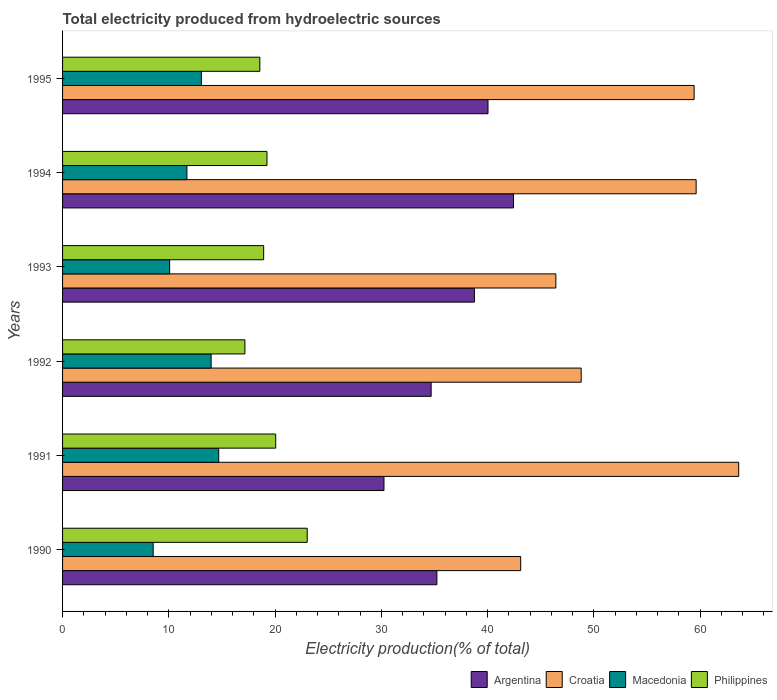How many different coloured bars are there?
Keep it short and to the point. 4. How many bars are there on the 1st tick from the top?
Your answer should be very brief. 4. What is the label of the 5th group of bars from the top?
Ensure brevity in your answer.  1991. In how many cases, is the number of bars for a given year not equal to the number of legend labels?
Ensure brevity in your answer.  0. What is the total electricity produced in Argentina in 1994?
Ensure brevity in your answer.  42.44. Across all years, what is the maximum total electricity produced in Philippines?
Provide a short and direct response. 23.03. Across all years, what is the minimum total electricity produced in Argentina?
Give a very brief answer. 30.25. In which year was the total electricity produced in Croatia maximum?
Keep it short and to the point. 1991. What is the total total electricity produced in Philippines in the graph?
Your answer should be compact. 116.98. What is the difference between the total electricity produced in Macedonia in 1993 and that in 1994?
Keep it short and to the point. -1.63. What is the difference between the total electricity produced in Argentina in 1990 and the total electricity produced in Croatia in 1992?
Your response must be concise. -13.58. What is the average total electricity produced in Argentina per year?
Your answer should be very brief. 36.9. In the year 1995, what is the difference between the total electricity produced in Argentina and total electricity produced in Philippines?
Offer a terse response. 21.47. What is the ratio of the total electricity produced in Macedonia in 1992 to that in 1995?
Your answer should be compact. 1.07. What is the difference between the highest and the second highest total electricity produced in Argentina?
Give a very brief answer. 2.4. What is the difference between the highest and the lowest total electricity produced in Croatia?
Your answer should be very brief. 20.52. In how many years, is the total electricity produced in Macedonia greater than the average total electricity produced in Macedonia taken over all years?
Give a very brief answer. 3. What does the 2nd bar from the top in 1991 represents?
Give a very brief answer. Macedonia. Is it the case that in every year, the sum of the total electricity produced in Macedonia and total electricity produced in Argentina is greater than the total electricity produced in Philippines?
Offer a terse response. Yes. How many bars are there?
Your response must be concise. 24. What is the difference between two consecutive major ticks on the X-axis?
Provide a succinct answer. 10. Does the graph contain any zero values?
Ensure brevity in your answer.  No. Does the graph contain grids?
Provide a short and direct response. No. Where does the legend appear in the graph?
Provide a succinct answer. Bottom right. How many legend labels are there?
Your response must be concise. 4. How are the legend labels stacked?
Give a very brief answer. Horizontal. What is the title of the graph?
Keep it short and to the point. Total electricity produced from hydroelectric sources. Does "Philippines" appear as one of the legend labels in the graph?
Your answer should be compact. Yes. What is the label or title of the X-axis?
Make the answer very short. Electricity production(% of total). What is the Electricity production(% of total) in Argentina in 1990?
Make the answer very short. 35.23. What is the Electricity production(% of total) in Croatia in 1990?
Ensure brevity in your answer.  43.12. What is the Electricity production(% of total) of Macedonia in 1990?
Your answer should be very brief. 8.53. What is the Electricity production(% of total) in Philippines in 1990?
Make the answer very short. 23.03. What is the Electricity production(% of total) of Argentina in 1991?
Provide a short and direct response. 30.25. What is the Electricity production(% of total) in Croatia in 1991?
Keep it short and to the point. 63.63. What is the Electricity production(% of total) in Macedonia in 1991?
Make the answer very short. 14.7. What is the Electricity production(% of total) in Philippines in 1991?
Your answer should be compact. 20.06. What is the Electricity production(% of total) of Argentina in 1992?
Provide a succinct answer. 34.69. What is the Electricity production(% of total) in Croatia in 1992?
Offer a terse response. 48.81. What is the Electricity production(% of total) in Macedonia in 1992?
Ensure brevity in your answer.  13.98. What is the Electricity production(% of total) of Philippines in 1992?
Your answer should be compact. 17.16. What is the Electricity production(% of total) in Argentina in 1993?
Offer a terse response. 38.76. What is the Electricity production(% of total) of Croatia in 1993?
Keep it short and to the point. 46.43. What is the Electricity production(% of total) of Macedonia in 1993?
Your response must be concise. 10.08. What is the Electricity production(% of total) in Philippines in 1993?
Your response must be concise. 18.92. What is the Electricity production(% of total) of Argentina in 1994?
Provide a succinct answer. 42.44. What is the Electricity production(% of total) of Croatia in 1994?
Offer a terse response. 59.63. What is the Electricity production(% of total) in Macedonia in 1994?
Offer a terse response. 11.7. What is the Electricity production(% of total) of Philippines in 1994?
Your response must be concise. 19.24. What is the Electricity production(% of total) in Argentina in 1995?
Keep it short and to the point. 40.04. What is the Electricity production(% of total) of Croatia in 1995?
Make the answer very short. 59.44. What is the Electricity production(% of total) of Macedonia in 1995?
Provide a succinct answer. 13.06. What is the Electricity production(% of total) of Philippines in 1995?
Give a very brief answer. 18.57. Across all years, what is the maximum Electricity production(% of total) in Argentina?
Your answer should be compact. 42.44. Across all years, what is the maximum Electricity production(% of total) of Croatia?
Offer a very short reply. 63.63. Across all years, what is the maximum Electricity production(% of total) of Macedonia?
Make the answer very short. 14.7. Across all years, what is the maximum Electricity production(% of total) in Philippines?
Make the answer very short. 23.03. Across all years, what is the minimum Electricity production(% of total) in Argentina?
Provide a succinct answer. 30.25. Across all years, what is the minimum Electricity production(% of total) in Croatia?
Offer a terse response. 43.12. Across all years, what is the minimum Electricity production(% of total) in Macedonia?
Give a very brief answer. 8.53. Across all years, what is the minimum Electricity production(% of total) of Philippines?
Your answer should be compact. 17.16. What is the total Electricity production(% of total) of Argentina in the graph?
Ensure brevity in your answer.  221.41. What is the total Electricity production(% of total) in Croatia in the graph?
Give a very brief answer. 321.05. What is the total Electricity production(% of total) in Macedonia in the graph?
Make the answer very short. 72.05. What is the total Electricity production(% of total) in Philippines in the graph?
Provide a short and direct response. 116.98. What is the difference between the Electricity production(% of total) in Argentina in 1990 and that in 1991?
Ensure brevity in your answer.  4.98. What is the difference between the Electricity production(% of total) in Croatia in 1990 and that in 1991?
Keep it short and to the point. -20.52. What is the difference between the Electricity production(% of total) of Macedonia in 1990 and that in 1991?
Make the answer very short. -6.17. What is the difference between the Electricity production(% of total) of Philippines in 1990 and that in 1991?
Offer a terse response. 2.97. What is the difference between the Electricity production(% of total) in Argentina in 1990 and that in 1992?
Your answer should be compact. 0.54. What is the difference between the Electricity production(% of total) in Croatia in 1990 and that in 1992?
Offer a terse response. -5.69. What is the difference between the Electricity production(% of total) in Macedonia in 1990 and that in 1992?
Offer a terse response. -5.45. What is the difference between the Electricity production(% of total) in Philippines in 1990 and that in 1992?
Offer a very short reply. 5.86. What is the difference between the Electricity production(% of total) of Argentina in 1990 and that in 1993?
Provide a succinct answer. -3.53. What is the difference between the Electricity production(% of total) of Croatia in 1990 and that in 1993?
Provide a succinct answer. -3.31. What is the difference between the Electricity production(% of total) in Macedonia in 1990 and that in 1993?
Ensure brevity in your answer.  -1.55. What is the difference between the Electricity production(% of total) in Philippines in 1990 and that in 1993?
Ensure brevity in your answer.  4.1. What is the difference between the Electricity production(% of total) in Argentina in 1990 and that in 1994?
Provide a succinct answer. -7.21. What is the difference between the Electricity production(% of total) in Croatia in 1990 and that in 1994?
Keep it short and to the point. -16.51. What is the difference between the Electricity production(% of total) of Macedonia in 1990 and that in 1994?
Make the answer very short. -3.17. What is the difference between the Electricity production(% of total) in Philippines in 1990 and that in 1994?
Ensure brevity in your answer.  3.79. What is the difference between the Electricity production(% of total) of Argentina in 1990 and that in 1995?
Your response must be concise. -4.81. What is the difference between the Electricity production(% of total) in Croatia in 1990 and that in 1995?
Offer a terse response. -16.32. What is the difference between the Electricity production(% of total) of Macedonia in 1990 and that in 1995?
Ensure brevity in your answer.  -4.54. What is the difference between the Electricity production(% of total) of Philippines in 1990 and that in 1995?
Offer a terse response. 4.46. What is the difference between the Electricity production(% of total) of Argentina in 1991 and that in 1992?
Give a very brief answer. -4.44. What is the difference between the Electricity production(% of total) in Croatia in 1991 and that in 1992?
Keep it short and to the point. 14.82. What is the difference between the Electricity production(% of total) in Macedonia in 1991 and that in 1992?
Your answer should be very brief. 0.71. What is the difference between the Electricity production(% of total) of Philippines in 1991 and that in 1992?
Your answer should be compact. 2.9. What is the difference between the Electricity production(% of total) of Argentina in 1991 and that in 1993?
Make the answer very short. -8.51. What is the difference between the Electricity production(% of total) of Croatia in 1991 and that in 1993?
Your answer should be compact. 17.21. What is the difference between the Electricity production(% of total) of Macedonia in 1991 and that in 1993?
Your response must be concise. 4.62. What is the difference between the Electricity production(% of total) of Philippines in 1991 and that in 1993?
Your answer should be very brief. 1.13. What is the difference between the Electricity production(% of total) in Argentina in 1991 and that in 1994?
Your answer should be very brief. -12.19. What is the difference between the Electricity production(% of total) in Croatia in 1991 and that in 1994?
Offer a terse response. 4. What is the difference between the Electricity production(% of total) in Macedonia in 1991 and that in 1994?
Offer a terse response. 2.99. What is the difference between the Electricity production(% of total) in Philippines in 1991 and that in 1994?
Give a very brief answer. 0.82. What is the difference between the Electricity production(% of total) in Argentina in 1991 and that in 1995?
Offer a terse response. -9.79. What is the difference between the Electricity production(% of total) in Croatia in 1991 and that in 1995?
Your answer should be compact. 4.19. What is the difference between the Electricity production(% of total) in Macedonia in 1991 and that in 1995?
Provide a short and direct response. 1.63. What is the difference between the Electricity production(% of total) in Philippines in 1991 and that in 1995?
Ensure brevity in your answer.  1.49. What is the difference between the Electricity production(% of total) of Argentina in 1992 and that in 1993?
Give a very brief answer. -4.07. What is the difference between the Electricity production(% of total) in Croatia in 1992 and that in 1993?
Make the answer very short. 2.38. What is the difference between the Electricity production(% of total) of Macedonia in 1992 and that in 1993?
Give a very brief answer. 3.9. What is the difference between the Electricity production(% of total) of Philippines in 1992 and that in 1993?
Keep it short and to the point. -1.76. What is the difference between the Electricity production(% of total) of Argentina in 1992 and that in 1994?
Offer a very short reply. -7.75. What is the difference between the Electricity production(% of total) in Croatia in 1992 and that in 1994?
Keep it short and to the point. -10.82. What is the difference between the Electricity production(% of total) of Macedonia in 1992 and that in 1994?
Offer a terse response. 2.28. What is the difference between the Electricity production(% of total) of Philippines in 1992 and that in 1994?
Offer a very short reply. -2.08. What is the difference between the Electricity production(% of total) in Argentina in 1992 and that in 1995?
Keep it short and to the point. -5.35. What is the difference between the Electricity production(% of total) of Croatia in 1992 and that in 1995?
Give a very brief answer. -10.63. What is the difference between the Electricity production(% of total) of Macedonia in 1992 and that in 1995?
Provide a short and direct response. 0.92. What is the difference between the Electricity production(% of total) of Philippines in 1992 and that in 1995?
Give a very brief answer. -1.4. What is the difference between the Electricity production(% of total) of Argentina in 1993 and that in 1994?
Your answer should be compact. -3.68. What is the difference between the Electricity production(% of total) in Croatia in 1993 and that in 1994?
Your response must be concise. -13.2. What is the difference between the Electricity production(% of total) in Macedonia in 1993 and that in 1994?
Ensure brevity in your answer.  -1.63. What is the difference between the Electricity production(% of total) of Philippines in 1993 and that in 1994?
Offer a terse response. -0.31. What is the difference between the Electricity production(% of total) in Argentina in 1993 and that in 1995?
Give a very brief answer. -1.28. What is the difference between the Electricity production(% of total) in Croatia in 1993 and that in 1995?
Provide a short and direct response. -13.01. What is the difference between the Electricity production(% of total) in Macedonia in 1993 and that in 1995?
Give a very brief answer. -2.99. What is the difference between the Electricity production(% of total) of Philippines in 1993 and that in 1995?
Your answer should be very brief. 0.36. What is the difference between the Electricity production(% of total) in Argentina in 1994 and that in 1995?
Offer a terse response. 2.4. What is the difference between the Electricity production(% of total) in Croatia in 1994 and that in 1995?
Keep it short and to the point. 0.19. What is the difference between the Electricity production(% of total) in Macedonia in 1994 and that in 1995?
Provide a succinct answer. -1.36. What is the difference between the Electricity production(% of total) in Philippines in 1994 and that in 1995?
Give a very brief answer. 0.67. What is the difference between the Electricity production(% of total) of Argentina in 1990 and the Electricity production(% of total) of Croatia in 1991?
Keep it short and to the point. -28.4. What is the difference between the Electricity production(% of total) of Argentina in 1990 and the Electricity production(% of total) of Macedonia in 1991?
Ensure brevity in your answer.  20.53. What is the difference between the Electricity production(% of total) in Argentina in 1990 and the Electricity production(% of total) in Philippines in 1991?
Ensure brevity in your answer.  15.17. What is the difference between the Electricity production(% of total) in Croatia in 1990 and the Electricity production(% of total) in Macedonia in 1991?
Provide a succinct answer. 28.42. What is the difference between the Electricity production(% of total) of Croatia in 1990 and the Electricity production(% of total) of Philippines in 1991?
Your response must be concise. 23.06. What is the difference between the Electricity production(% of total) in Macedonia in 1990 and the Electricity production(% of total) in Philippines in 1991?
Ensure brevity in your answer.  -11.53. What is the difference between the Electricity production(% of total) of Argentina in 1990 and the Electricity production(% of total) of Croatia in 1992?
Provide a short and direct response. -13.58. What is the difference between the Electricity production(% of total) of Argentina in 1990 and the Electricity production(% of total) of Macedonia in 1992?
Provide a short and direct response. 21.25. What is the difference between the Electricity production(% of total) in Argentina in 1990 and the Electricity production(% of total) in Philippines in 1992?
Provide a short and direct response. 18.07. What is the difference between the Electricity production(% of total) in Croatia in 1990 and the Electricity production(% of total) in Macedonia in 1992?
Keep it short and to the point. 29.13. What is the difference between the Electricity production(% of total) in Croatia in 1990 and the Electricity production(% of total) in Philippines in 1992?
Provide a succinct answer. 25.95. What is the difference between the Electricity production(% of total) of Macedonia in 1990 and the Electricity production(% of total) of Philippines in 1992?
Provide a short and direct response. -8.64. What is the difference between the Electricity production(% of total) in Argentina in 1990 and the Electricity production(% of total) in Croatia in 1993?
Give a very brief answer. -11.2. What is the difference between the Electricity production(% of total) of Argentina in 1990 and the Electricity production(% of total) of Macedonia in 1993?
Provide a succinct answer. 25.15. What is the difference between the Electricity production(% of total) of Argentina in 1990 and the Electricity production(% of total) of Philippines in 1993?
Ensure brevity in your answer.  16.31. What is the difference between the Electricity production(% of total) in Croatia in 1990 and the Electricity production(% of total) in Macedonia in 1993?
Ensure brevity in your answer.  33.04. What is the difference between the Electricity production(% of total) in Croatia in 1990 and the Electricity production(% of total) in Philippines in 1993?
Provide a succinct answer. 24.19. What is the difference between the Electricity production(% of total) of Macedonia in 1990 and the Electricity production(% of total) of Philippines in 1993?
Keep it short and to the point. -10.4. What is the difference between the Electricity production(% of total) of Argentina in 1990 and the Electricity production(% of total) of Croatia in 1994?
Your response must be concise. -24.4. What is the difference between the Electricity production(% of total) of Argentina in 1990 and the Electricity production(% of total) of Macedonia in 1994?
Offer a very short reply. 23.53. What is the difference between the Electricity production(% of total) in Argentina in 1990 and the Electricity production(% of total) in Philippines in 1994?
Your answer should be compact. 15.99. What is the difference between the Electricity production(% of total) of Croatia in 1990 and the Electricity production(% of total) of Macedonia in 1994?
Offer a very short reply. 31.41. What is the difference between the Electricity production(% of total) in Croatia in 1990 and the Electricity production(% of total) in Philippines in 1994?
Ensure brevity in your answer.  23.88. What is the difference between the Electricity production(% of total) in Macedonia in 1990 and the Electricity production(% of total) in Philippines in 1994?
Your response must be concise. -10.71. What is the difference between the Electricity production(% of total) of Argentina in 1990 and the Electricity production(% of total) of Croatia in 1995?
Offer a terse response. -24.21. What is the difference between the Electricity production(% of total) of Argentina in 1990 and the Electricity production(% of total) of Macedonia in 1995?
Offer a terse response. 22.17. What is the difference between the Electricity production(% of total) in Argentina in 1990 and the Electricity production(% of total) in Philippines in 1995?
Your response must be concise. 16.66. What is the difference between the Electricity production(% of total) of Croatia in 1990 and the Electricity production(% of total) of Macedonia in 1995?
Keep it short and to the point. 30.05. What is the difference between the Electricity production(% of total) of Croatia in 1990 and the Electricity production(% of total) of Philippines in 1995?
Give a very brief answer. 24.55. What is the difference between the Electricity production(% of total) of Macedonia in 1990 and the Electricity production(% of total) of Philippines in 1995?
Your response must be concise. -10.04. What is the difference between the Electricity production(% of total) of Argentina in 1991 and the Electricity production(% of total) of Croatia in 1992?
Give a very brief answer. -18.56. What is the difference between the Electricity production(% of total) of Argentina in 1991 and the Electricity production(% of total) of Macedonia in 1992?
Give a very brief answer. 16.27. What is the difference between the Electricity production(% of total) of Argentina in 1991 and the Electricity production(% of total) of Philippines in 1992?
Ensure brevity in your answer.  13.09. What is the difference between the Electricity production(% of total) in Croatia in 1991 and the Electricity production(% of total) in Macedonia in 1992?
Provide a succinct answer. 49.65. What is the difference between the Electricity production(% of total) in Croatia in 1991 and the Electricity production(% of total) in Philippines in 1992?
Ensure brevity in your answer.  46.47. What is the difference between the Electricity production(% of total) of Macedonia in 1991 and the Electricity production(% of total) of Philippines in 1992?
Offer a very short reply. -2.47. What is the difference between the Electricity production(% of total) in Argentina in 1991 and the Electricity production(% of total) in Croatia in 1993?
Your answer should be very brief. -16.18. What is the difference between the Electricity production(% of total) of Argentina in 1991 and the Electricity production(% of total) of Macedonia in 1993?
Provide a short and direct response. 20.17. What is the difference between the Electricity production(% of total) of Argentina in 1991 and the Electricity production(% of total) of Philippines in 1993?
Your response must be concise. 11.33. What is the difference between the Electricity production(% of total) of Croatia in 1991 and the Electricity production(% of total) of Macedonia in 1993?
Give a very brief answer. 53.55. What is the difference between the Electricity production(% of total) in Croatia in 1991 and the Electricity production(% of total) in Philippines in 1993?
Keep it short and to the point. 44.71. What is the difference between the Electricity production(% of total) in Macedonia in 1991 and the Electricity production(% of total) in Philippines in 1993?
Your answer should be compact. -4.23. What is the difference between the Electricity production(% of total) of Argentina in 1991 and the Electricity production(% of total) of Croatia in 1994?
Offer a very short reply. -29.38. What is the difference between the Electricity production(% of total) in Argentina in 1991 and the Electricity production(% of total) in Macedonia in 1994?
Provide a succinct answer. 18.55. What is the difference between the Electricity production(% of total) of Argentina in 1991 and the Electricity production(% of total) of Philippines in 1994?
Provide a short and direct response. 11.01. What is the difference between the Electricity production(% of total) in Croatia in 1991 and the Electricity production(% of total) in Macedonia in 1994?
Your answer should be very brief. 51.93. What is the difference between the Electricity production(% of total) in Croatia in 1991 and the Electricity production(% of total) in Philippines in 1994?
Provide a succinct answer. 44.39. What is the difference between the Electricity production(% of total) in Macedonia in 1991 and the Electricity production(% of total) in Philippines in 1994?
Keep it short and to the point. -4.54. What is the difference between the Electricity production(% of total) in Argentina in 1991 and the Electricity production(% of total) in Croatia in 1995?
Ensure brevity in your answer.  -29.19. What is the difference between the Electricity production(% of total) in Argentina in 1991 and the Electricity production(% of total) in Macedonia in 1995?
Your answer should be very brief. 17.19. What is the difference between the Electricity production(% of total) of Argentina in 1991 and the Electricity production(% of total) of Philippines in 1995?
Offer a very short reply. 11.68. What is the difference between the Electricity production(% of total) of Croatia in 1991 and the Electricity production(% of total) of Macedonia in 1995?
Provide a succinct answer. 50.57. What is the difference between the Electricity production(% of total) of Croatia in 1991 and the Electricity production(% of total) of Philippines in 1995?
Keep it short and to the point. 45.07. What is the difference between the Electricity production(% of total) of Macedonia in 1991 and the Electricity production(% of total) of Philippines in 1995?
Ensure brevity in your answer.  -3.87. What is the difference between the Electricity production(% of total) in Argentina in 1992 and the Electricity production(% of total) in Croatia in 1993?
Make the answer very short. -11.74. What is the difference between the Electricity production(% of total) in Argentina in 1992 and the Electricity production(% of total) in Macedonia in 1993?
Your answer should be very brief. 24.61. What is the difference between the Electricity production(% of total) in Argentina in 1992 and the Electricity production(% of total) in Philippines in 1993?
Ensure brevity in your answer.  15.76. What is the difference between the Electricity production(% of total) in Croatia in 1992 and the Electricity production(% of total) in Macedonia in 1993?
Your answer should be compact. 38.73. What is the difference between the Electricity production(% of total) in Croatia in 1992 and the Electricity production(% of total) in Philippines in 1993?
Ensure brevity in your answer.  29.88. What is the difference between the Electricity production(% of total) in Macedonia in 1992 and the Electricity production(% of total) in Philippines in 1993?
Provide a short and direct response. -4.94. What is the difference between the Electricity production(% of total) of Argentina in 1992 and the Electricity production(% of total) of Croatia in 1994?
Keep it short and to the point. -24.94. What is the difference between the Electricity production(% of total) of Argentina in 1992 and the Electricity production(% of total) of Macedonia in 1994?
Keep it short and to the point. 22.99. What is the difference between the Electricity production(% of total) in Argentina in 1992 and the Electricity production(% of total) in Philippines in 1994?
Give a very brief answer. 15.45. What is the difference between the Electricity production(% of total) in Croatia in 1992 and the Electricity production(% of total) in Macedonia in 1994?
Ensure brevity in your answer.  37.11. What is the difference between the Electricity production(% of total) of Croatia in 1992 and the Electricity production(% of total) of Philippines in 1994?
Offer a very short reply. 29.57. What is the difference between the Electricity production(% of total) in Macedonia in 1992 and the Electricity production(% of total) in Philippines in 1994?
Provide a succinct answer. -5.26. What is the difference between the Electricity production(% of total) in Argentina in 1992 and the Electricity production(% of total) in Croatia in 1995?
Ensure brevity in your answer.  -24.75. What is the difference between the Electricity production(% of total) of Argentina in 1992 and the Electricity production(% of total) of Macedonia in 1995?
Your answer should be compact. 21.63. What is the difference between the Electricity production(% of total) in Argentina in 1992 and the Electricity production(% of total) in Philippines in 1995?
Ensure brevity in your answer.  16.12. What is the difference between the Electricity production(% of total) in Croatia in 1992 and the Electricity production(% of total) in Macedonia in 1995?
Your answer should be compact. 35.75. What is the difference between the Electricity production(% of total) in Croatia in 1992 and the Electricity production(% of total) in Philippines in 1995?
Ensure brevity in your answer.  30.24. What is the difference between the Electricity production(% of total) of Macedonia in 1992 and the Electricity production(% of total) of Philippines in 1995?
Make the answer very short. -4.58. What is the difference between the Electricity production(% of total) in Argentina in 1993 and the Electricity production(% of total) in Croatia in 1994?
Make the answer very short. -20.87. What is the difference between the Electricity production(% of total) of Argentina in 1993 and the Electricity production(% of total) of Macedonia in 1994?
Provide a short and direct response. 27.06. What is the difference between the Electricity production(% of total) of Argentina in 1993 and the Electricity production(% of total) of Philippines in 1994?
Offer a very short reply. 19.52. What is the difference between the Electricity production(% of total) of Croatia in 1993 and the Electricity production(% of total) of Macedonia in 1994?
Make the answer very short. 34.72. What is the difference between the Electricity production(% of total) in Croatia in 1993 and the Electricity production(% of total) in Philippines in 1994?
Your answer should be compact. 27.19. What is the difference between the Electricity production(% of total) in Macedonia in 1993 and the Electricity production(% of total) in Philippines in 1994?
Ensure brevity in your answer.  -9.16. What is the difference between the Electricity production(% of total) in Argentina in 1993 and the Electricity production(% of total) in Croatia in 1995?
Your answer should be compact. -20.68. What is the difference between the Electricity production(% of total) in Argentina in 1993 and the Electricity production(% of total) in Macedonia in 1995?
Your response must be concise. 25.7. What is the difference between the Electricity production(% of total) of Argentina in 1993 and the Electricity production(% of total) of Philippines in 1995?
Give a very brief answer. 20.19. What is the difference between the Electricity production(% of total) in Croatia in 1993 and the Electricity production(% of total) in Macedonia in 1995?
Your response must be concise. 33.36. What is the difference between the Electricity production(% of total) of Croatia in 1993 and the Electricity production(% of total) of Philippines in 1995?
Offer a terse response. 27.86. What is the difference between the Electricity production(% of total) in Macedonia in 1993 and the Electricity production(% of total) in Philippines in 1995?
Your response must be concise. -8.49. What is the difference between the Electricity production(% of total) of Argentina in 1994 and the Electricity production(% of total) of Croatia in 1995?
Give a very brief answer. -17. What is the difference between the Electricity production(% of total) in Argentina in 1994 and the Electricity production(% of total) in Macedonia in 1995?
Ensure brevity in your answer.  29.38. What is the difference between the Electricity production(% of total) of Argentina in 1994 and the Electricity production(% of total) of Philippines in 1995?
Give a very brief answer. 23.87. What is the difference between the Electricity production(% of total) of Croatia in 1994 and the Electricity production(% of total) of Macedonia in 1995?
Your answer should be compact. 46.56. What is the difference between the Electricity production(% of total) of Croatia in 1994 and the Electricity production(% of total) of Philippines in 1995?
Provide a succinct answer. 41.06. What is the difference between the Electricity production(% of total) in Macedonia in 1994 and the Electricity production(% of total) in Philippines in 1995?
Your response must be concise. -6.86. What is the average Electricity production(% of total) of Argentina per year?
Offer a very short reply. 36.9. What is the average Electricity production(% of total) in Croatia per year?
Provide a short and direct response. 53.51. What is the average Electricity production(% of total) of Macedonia per year?
Provide a short and direct response. 12.01. What is the average Electricity production(% of total) in Philippines per year?
Offer a terse response. 19.5. In the year 1990, what is the difference between the Electricity production(% of total) of Argentina and Electricity production(% of total) of Croatia?
Provide a succinct answer. -7.88. In the year 1990, what is the difference between the Electricity production(% of total) in Argentina and Electricity production(% of total) in Macedonia?
Offer a very short reply. 26.7. In the year 1990, what is the difference between the Electricity production(% of total) in Argentina and Electricity production(% of total) in Philippines?
Your answer should be compact. 12.2. In the year 1990, what is the difference between the Electricity production(% of total) of Croatia and Electricity production(% of total) of Macedonia?
Offer a terse response. 34.59. In the year 1990, what is the difference between the Electricity production(% of total) of Croatia and Electricity production(% of total) of Philippines?
Your answer should be compact. 20.09. In the year 1990, what is the difference between the Electricity production(% of total) in Macedonia and Electricity production(% of total) in Philippines?
Offer a terse response. -14.5. In the year 1991, what is the difference between the Electricity production(% of total) of Argentina and Electricity production(% of total) of Croatia?
Provide a short and direct response. -33.38. In the year 1991, what is the difference between the Electricity production(% of total) of Argentina and Electricity production(% of total) of Macedonia?
Offer a terse response. 15.55. In the year 1991, what is the difference between the Electricity production(% of total) of Argentina and Electricity production(% of total) of Philippines?
Keep it short and to the point. 10.19. In the year 1991, what is the difference between the Electricity production(% of total) in Croatia and Electricity production(% of total) in Macedonia?
Make the answer very short. 48.94. In the year 1991, what is the difference between the Electricity production(% of total) in Croatia and Electricity production(% of total) in Philippines?
Provide a short and direct response. 43.57. In the year 1991, what is the difference between the Electricity production(% of total) of Macedonia and Electricity production(% of total) of Philippines?
Provide a succinct answer. -5.36. In the year 1992, what is the difference between the Electricity production(% of total) in Argentina and Electricity production(% of total) in Croatia?
Make the answer very short. -14.12. In the year 1992, what is the difference between the Electricity production(% of total) in Argentina and Electricity production(% of total) in Macedonia?
Offer a very short reply. 20.71. In the year 1992, what is the difference between the Electricity production(% of total) of Argentina and Electricity production(% of total) of Philippines?
Provide a succinct answer. 17.53. In the year 1992, what is the difference between the Electricity production(% of total) in Croatia and Electricity production(% of total) in Macedonia?
Provide a succinct answer. 34.83. In the year 1992, what is the difference between the Electricity production(% of total) in Croatia and Electricity production(% of total) in Philippines?
Offer a terse response. 31.65. In the year 1992, what is the difference between the Electricity production(% of total) of Macedonia and Electricity production(% of total) of Philippines?
Offer a very short reply. -3.18. In the year 1993, what is the difference between the Electricity production(% of total) in Argentina and Electricity production(% of total) in Croatia?
Provide a short and direct response. -7.67. In the year 1993, what is the difference between the Electricity production(% of total) in Argentina and Electricity production(% of total) in Macedonia?
Make the answer very short. 28.68. In the year 1993, what is the difference between the Electricity production(% of total) of Argentina and Electricity production(% of total) of Philippines?
Offer a terse response. 19.84. In the year 1993, what is the difference between the Electricity production(% of total) of Croatia and Electricity production(% of total) of Macedonia?
Make the answer very short. 36.35. In the year 1993, what is the difference between the Electricity production(% of total) of Croatia and Electricity production(% of total) of Philippines?
Ensure brevity in your answer.  27.5. In the year 1993, what is the difference between the Electricity production(% of total) of Macedonia and Electricity production(% of total) of Philippines?
Offer a very short reply. -8.85. In the year 1994, what is the difference between the Electricity production(% of total) of Argentina and Electricity production(% of total) of Croatia?
Offer a terse response. -17.19. In the year 1994, what is the difference between the Electricity production(% of total) in Argentina and Electricity production(% of total) in Macedonia?
Offer a terse response. 30.74. In the year 1994, what is the difference between the Electricity production(% of total) in Argentina and Electricity production(% of total) in Philippines?
Provide a succinct answer. 23.2. In the year 1994, what is the difference between the Electricity production(% of total) in Croatia and Electricity production(% of total) in Macedonia?
Offer a very short reply. 47.93. In the year 1994, what is the difference between the Electricity production(% of total) in Croatia and Electricity production(% of total) in Philippines?
Offer a terse response. 40.39. In the year 1994, what is the difference between the Electricity production(% of total) in Macedonia and Electricity production(% of total) in Philippines?
Your response must be concise. -7.54. In the year 1995, what is the difference between the Electricity production(% of total) of Argentina and Electricity production(% of total) of Croatia?
Provide a succinct answer. -19.4. In the year 1995, what is the difference between the Electricity production(% of total) of Argentina and Electricity production(% of total) of Macedonia?
Give a very brief answer. 26.98. In the year 1995, what is the difference between the Electricity production(% of total) of Argentina and Electricity production(% of total) of Philippines?
Make the answer very short. 21.47. In the year 1995, what is the difference between the Electricity production(% of total) in Croatia and Electricity production(% of total) in Macedonia?
Your answer should be very brief. 46.38. In the year 1995, what is the difference between the Electricity production(% of total) in Croatia and Electricity production(% of total) in Philippines?
Ensure brevity in your answer.  40.87. In the year 1995, what is the difference between the Electricity production(% of total) in Macedonia and Electricity production(% of total) in Philippines?
Your response must be concise. -5.5. What is the ratio of the Electricity production(% of total) of Argentina in 1990 to that in 1991?
Offer a very short reply. 1.16. What is the ratio of the Electricity production(% of total) of Croatia in 1990 to that in 1991?
Your answer should be very brief. 0.68. What is the ratio of the Electricity production(% of total) of Macedonia in 1990 to that in 1991?
Your answer should be very brief. 0.58. What is the ratio of the Electricity production(% of total) of Philippines in 1990 to that in 1991?
Offer a terse response. 1.15. What is the ratio of the Electricity production(% of total) in Argentina in 1990 to that in 1992?
Ensure brevity in your answer.  1.02. What is the ratio of the Electricity production(% of total) of Croatia in 1990 to that in 1992?
Your answer should be compact. 0.88. What is the ratio of the Electricity production(% of total) in Macedonia in 1990 to that in 1992?
Provide a succinct answer. 0.61. What is the ratio of the Electricity production(% of total) of Philippines in 1990 to that in 1992?
Provide a succinct answer. 1.34. What is the ratio of the Electricity production(% of total) in Argentina in 1990 to that in 1993?
Provide a succinct answer. 0.91. What is the ratio of the Electricity production(% of total) of Croatia in 1990 to that in 1993?
Provide a succinct answer. 0.93. What is the ratio of the Electricity production(% of total) of Macedonia in 1990 to that in 1993?
Give a very brief answer. 0.85. What is the ratio of the Electricity production(% of total) of Philippines in 1990 to that in 1993?
Offer a very short reply. 1.22. What is the ratio of the Electricity production(% of total) in Argentina in 1990 to that in 1994?
Your answer should be compact. 0.83. What is the ratio of the Electricity production(% of total) in Croatia in 1990 to that in 1994?
Ensure brevity in your answer.  0.72. What is the ratio of the Electricity production(% of total) of Macedonia in 1990 to that in 1994?
Make the answer very short. 0.73. What is the ratio of the Electricity production(% of total) in Philippines in 1990 to that in 1994?
Provide a short and direct response. 1.2. What is the ratio of the Electricity production(% of total) in Argentina in 1990 to that in 1995?
Offer a very short reply. 0.88. What is the ratio of the Electricity production(% of total) of Croatia in 1990 to that in 1995?
Offer a terse response. 0.73. What is the ratio of the Electricity production(% of total) in Macedonia in 1990 to that in 1995?
Give a very brief answer. 0.65. What is the ratio of the Electricity production(% of total) of Philippines in 1990 to that in 1995?
Your answer should be very brief. 1.24. What is the ratio of the Electricity production(% of total) in Argentina in 1991 to that in 1992?
Provide a succinct answer. 0.87. What is the ratio of the Electricity production(% of total) of Croatia in 1991 to that in 1992?
Make the answer very short. 1.3. What is the ratio of the Electricity production(% of total) in Macedonia in 1991 to that in 1992?
Provide a succinct answer. 1.05. What is the ratio of the Electricity production(% of total) in Philippines in 1991 to that in 1992?
Provide a short and direct response. 1.17. What is the ratio of the Electricity production(% of total) of Argentina in 1991 to that in 1993?
Your answer should be very brief. 0.78. What is the ratio of the Electricity production(% of total) in Croatia in 1991 to that in 1993?
Provide a short and direct response. 1.37. What is the ratio of the Electricity production(% of total) in Macedonia in 1991 to that in 1993?
Provide a short and direct response. 1.46. What is the ratio of the Electricity production(% of total) in Philippines in 1991 to that in 1993?
Provide a short and direct response. 1.06. What is the ratio of the Electricity production(% of total) in Argentina in 1991 to that in 1994?
Your answer should be very brief. 0.71. What is the ratio of the Electricity production(% of total) of Croatia in 1991 to that in 1994?
Your answer should be compact. 1.07. What is the ratio of the Electricity production(% of total) of Macedonia in 1991 to that in 1994?
Your answer should be compact. 1.26. What is the ratio of the Electricity production(% of total) in Philippines in 1991 to that in 1994?
Your answer should be very brief. 1.04. What is the ratio of the Electricity production(% of total) in Argentina in 1991 to that in 1995?
Give a very brief answer. 0.76. What is the ratio of the Electricity production(% of total) in Croatia in 1991 to that in 1995?
Make the answer very short. 1.07. What is the ratio of the Electricity production(% of total) in Macedonia in 1991 to that in 1995?
Provide a succinct answer. 1.13. What is the ratio of the Electricity production(% of total) in Philippines in 1991 to that in 1995?
Offer a terse response. 1.08. What is the ratio of the Electricity production(% of total) of Argentina in 1992 to that in 1993?
Make the answer very short. 0.89. What is the ratio of the Electricity production(% of total) of Croatia in 1992 to that in 1993?
Ensure brevity in your answer.  1.05. What is the ratio of the Electricity production(% of total) in Macedonia in 1992 to that in 1993?
Ensure brevity in your answer.  1.39. What is the ratio of the Electricity production(% of total) of Philippines in 1992 to that in 1993?
Provide a short and direct response. 0.91. What is the ratio of the Electricity production(% of total) of Argentina in 1992 to that in 1994?
Keep it short and to the point. 0.82. What is the ratio of the Electricity production(% of total) in Croatia in 1992 to that in 1994?
Your response must be concise. 0.82. What is the ratio of the Electricity production(% of total) in Macedonia in 1992 to that in 1994?
Keep it short and to the point. 1.19. What is the ratio of the Electricity production(% of total) of Philippines in 1992 to that in 1994?
Your response must be concise. 0.89. What is the ratio of the Electricity production(% of total) of Argentina in 1992 to that in 1995?
Provide a short and direct response. 0.87. What is the ratio of the Electricity production(% of total) of Croatia in 1992 to that in 1995?
Provide a succinct answer. 0.82. What is the ratio of the Electricity production(% of total) of Macedonia in 1992 to that in 1995?
Offer a very short reply. 1.07. What is the ratio of the Electricity production(% of total) in Philippines in 1992 to that in 1995?
Offer a very short reply. 0.92. What is the ratio of the Electricity production(% of total) of Argentina in 1993 to that in 1994?
Offer a terse response. 0.91. What is the ratio of the Electricity production(% of total) of Croatia in 1993 to that in 1994?
Provide a short and direct response. 0.78. What is the ratio of the Electricity production(% of total) in Macedonia in 1993 to that in 1994?
Provide a short and direct response. 0.86. What is the ratio of the Electricity production(% of total) of Philippines in 1993 to that in 1994?
Your answer should be compact. 0.98. What is the ratio of the Electricity production(% of total) of Argentina in 1993 to that in 1995?
Keep it short and to the point. 0.97. What is the ratio of the Electricity production(% of total) in Croatia in 1993 to that in 1995?
Offer a terse response. 0.78. What is the ratio of the Electricity production(% of total) of Macedonia in 1993 to that in 1995?
Provide a succinct answer. 0.77. What is the ratio of the Electricity production(% of total) in Philippines in 1993 to that in 1995?
Your answer should be compact. 1.02. What is the ratio of the Electricity production(% of total) in Argentina in 1994 to that in 1995?
Your answer should be very brief. 1.06. What is the ratio of the Electricity production(% of total) of Macedonia in 1994 to that in 1995?
Offer a very short reply. 0.9. What is the ratio of the Electricity production(% of total) in Philippines in 1994 to that in 1995?
Your answer should be very brief. 1.04. What is the difference between the highest and the second highest Electricity production(% of total) in Argentina?
Offer a very short reply. 2.4. What is the difference between the highest and the second highest Electricity production(% of total) of Croatia?
Provide a short and direct response. 4. What is the difference between the highest and the second highest Electricity production(% of total) of Macedonia?
Ensure brevity in your answer.  0.71. What is the difference between the highest and the second highest Electricity production(% of total) in Philippines?
Provide a short and direct response. 2.97. What is the difference between the highest and the lowest Electricity production(% of total) of Argentina?
Give a very brief answer. 12.19. What is the difference between the highest and the lowest Electricity production(% of total) of Croatia?
Offer a terse response. 20.52. What is the difference between the highest and the lowest Electricity production(% of total) of Macedonia?
Your response must be concise. 6.17. What is the difference between the highest and the lowest Electricity production(% of total) in Philippines?
Your response must be concise. 5.86. 